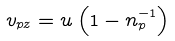Convert formula to latex. <formula><loc_0><loc_0><loc_500><loc_500>v _ { p z } = u \left ( 1 - n _ { p } ^ { - 1 } \right )</formula> 